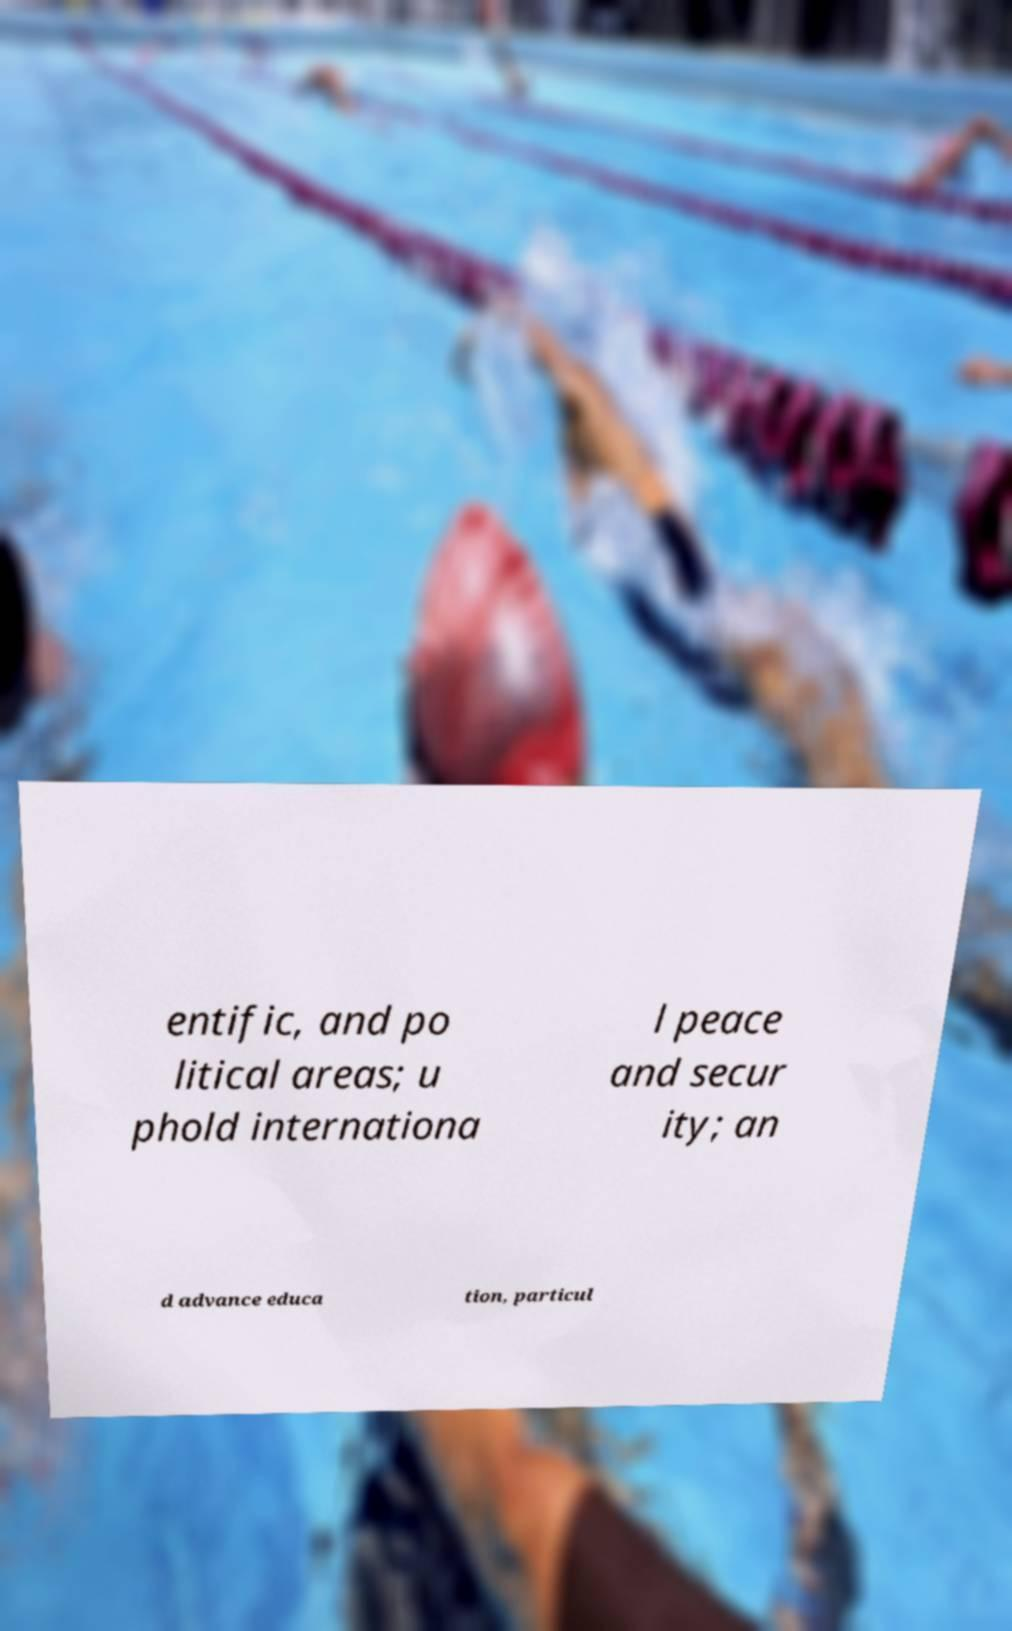There's text embedded in this image that I need extracted. Can you transcribe it verbatim? entific, and po litical areas; u phold internationa l peace and secur ity; an d advance educa tion, particul 